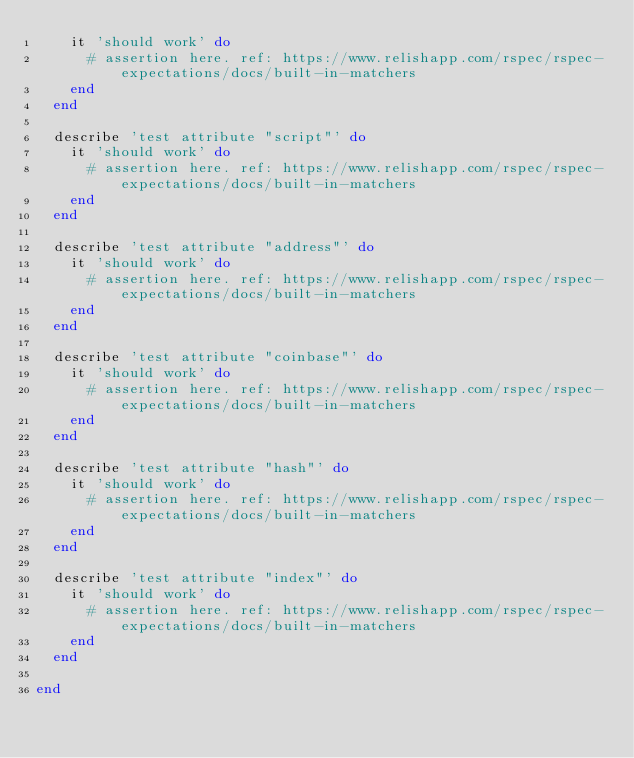Convert code to text. <code><loc_0><loc_0><loc_500><loc_500><_Ruby_>    it 'should work' do
      # assertion here. ref: https://www.relishapp.com/rspec/rspec-expectations/docs/built-in-matchers
    end
  end

  describe 'test attribute "script"' do
    it 'should work' do
      # assertion here. ref: https://www.relishapp.com/rspec/rspec-expectations/docs/built-in-matchers
    end
  end

  describe 'test attribute "address"' do
    it 'should work' do
      # assertion here. ref: https://www.relishapp.com/rspec/rspec-expectations/docs/built-in-matchers
    end
  end

  describe 'test attribute "coinbase"' do
    it 'should work' do
      # assertion here. ref: https://www.relishapp.com/rspec/rspec-expectations/docs/built-in-matchers
    end
  end

  describe 'test attribute "hash"' do
    it 'should work' do
      # assertion here. ref: https://www.relishapp.com/rspec/rspec-expectations/docs/built-in-matchers
    end
  end

  describe 'test attribute "index"' do
    it 'should work' do
      # assertion here. ref: https://www.relishapp.com/rspec/rspec-expectations/docs/built-in-matchers
    end
  end

end
</code> 